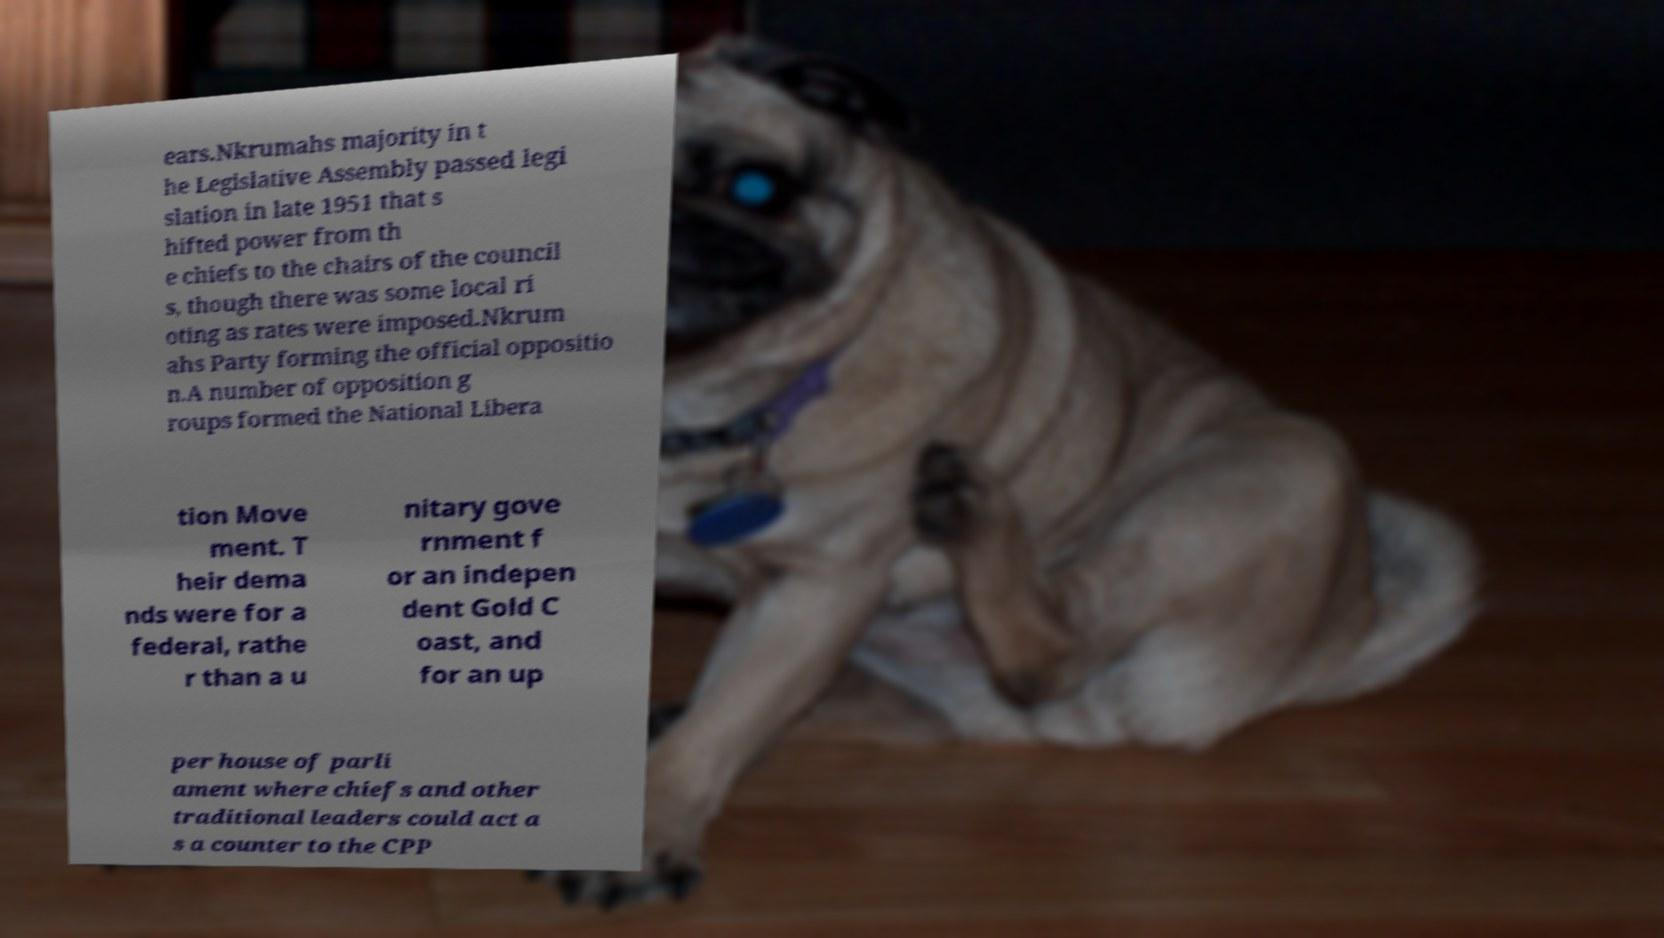What messages or text are displayed in this image? I need them in a readable, typed format. ears.Nkrumahs majority in t he Legislative Assembly passed legi slation in late 1951 that s hifted power from th e chiefs to the chairs of the council s, though there was some local ri oting as rates were imposed.Nkrum ahs Party forming the official oppositio n.A number of opposition g roups formed the National Libera tion Move ment. T heir dema nds were for a federal, rathe r than a u nitary gove rnment f or an indepen dent Gold C oast, and for an up per house of parli ament where chiefs and other traditional leaders could act a s a counter to the CPP 